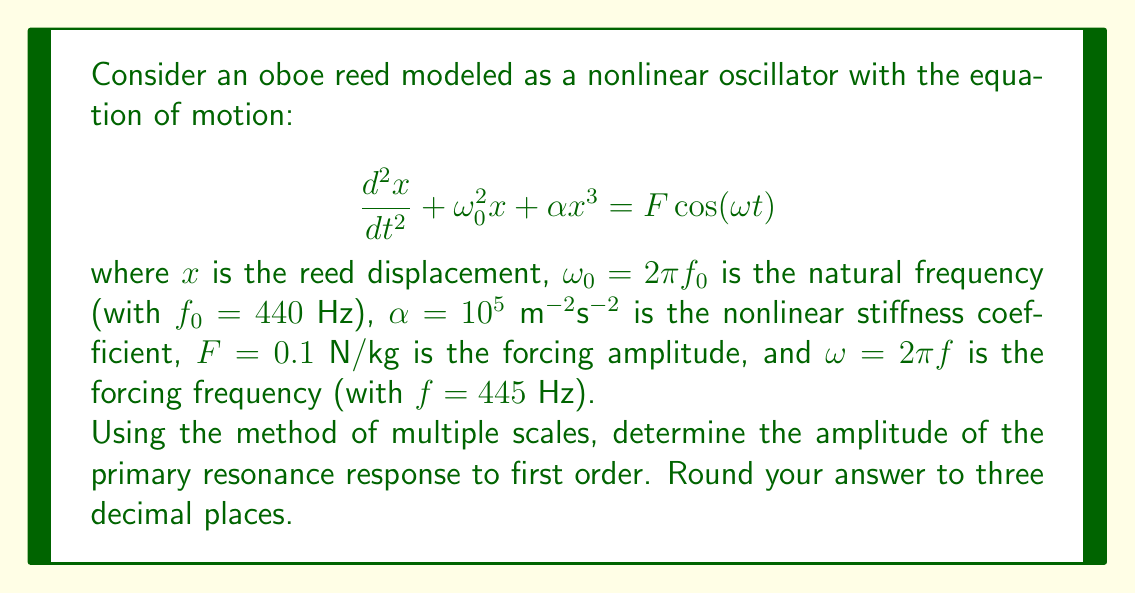Provide a solution to this math problem. To solve this problem, we'll use the method of multiple scales:

1) Introduce a small parameter $\epsilon$ and rescale the variables:
   $\alpha = \epsilon \hat{\alpha}$, $F = \epsilon \hat{F}$

2) Introduce multiple time scales:
   $T_0 = t$, $T_1 = \epsilon t$

3) Expand the solution in powers of $\epsilon$:
   $x(t) = x_0(T_0, T_1) + \epsilon x_1(T_0, T_1) + O(\epsilon^2)$

4) Express the frequency nearness to resonance:
   $\omega = \omega_0 + \epsilon \sigma$, where $\sigma$ is a detuning parameter

5) Substitute these expansions into the original equation and collect terms of like powers of $\epsilon$:

   $O(1)$: $D_0^2x_0 + \omega_0^2x_0 = 0$
   $O(\epsilon)$: $D_0^2x_1 + \omega_0^2x_1 = -2D_0D_1x_0 - \hat{\alpha}x_0^3 + \hat{F}\cos(\omega_0 T_0 + \sigma T_1)$

   where $D_n = \frac{\partial}{\partial T_n}$

6) Solve the $O(1)$ equation:
   $x_0 = A(T_1)e^{i\omega_0 T_0} + \text{c.c.}$

7) Substitute this into the $O(\epsilon)$ equation and eliminate secular terms:

   $-2i\omega_0(A' + \frac{1}{2}i\sigma A) - \frac{3}{2}\hat{\alpha}|A|^2A + \frac{1}{2}\hat{F} = 0$

8) Express $A$ in polar form: $A = \frac{1}{2}ae^{i\beta}$

9) Separate real and imaginary parts to get amplitude and phase equations:

   $a' = -\frac{\hat{F}}{2\omega_0}\sin\gamma$
   $a\gamma' = \sigma a - \frac{3\hat{\alpha}}{8\omega_0}a^3 - \frac{\hat{F}}{2\omega_0}\cos\gamma$

   where $\gamma = \sigma T_1 - \beta$

10) For steady-state solution, set $a' = \gamma' = 0$:

    $\frac{\hat{F}^2}{4\omega_0^2} = a^2[(\sigma - \frac{3\hat{\alpha}}{8\omega_0}a^2)^2 + (\frac{\epsilon \omega_0}{2})^2]$

11) Solve this equation numerically with the given parameters:
    $\omega_0 = 2\pi(440)$, $\hat{\alpha} = 10^5/\epsilon$, $\hat{F} = 0.1/\epsilon$, $\sigma = 2\pi(445-440)$

12) The solution gives the amplitude $a$ of the primary resonance response.
Answer: $a \approx 0.003$ m 